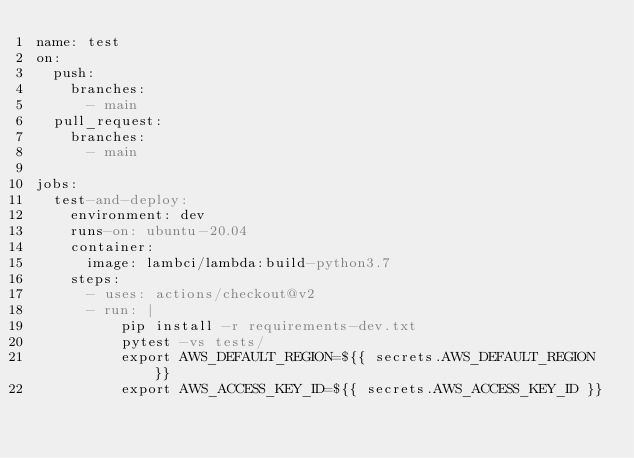Convert code to text. <code><loc_0><loc_0><loc_500><loc_500><_YAML_>name: test
on:
  push:
    branches:
      - main
  pull_request:
    branches:
      - main

jobs:
  test-and-deploy:
    environment: dev
    runs-on: ubuntu-20.04
    container:
      image: lambci/lambda:build-python3.7
    steps:
      - uses: actions/checkout@v2
      - run: |
          pip install -r requirements-dev.txt
          pytest -vs tests/
          export AWS_DEFAULT_REGION=${{ secrets.AWS_DEFAULT_REGION }}
          export AWS_ACCESS_KEY_ID=${{ secrets.AWS_ACCESS_KEY_ID }}</code> 